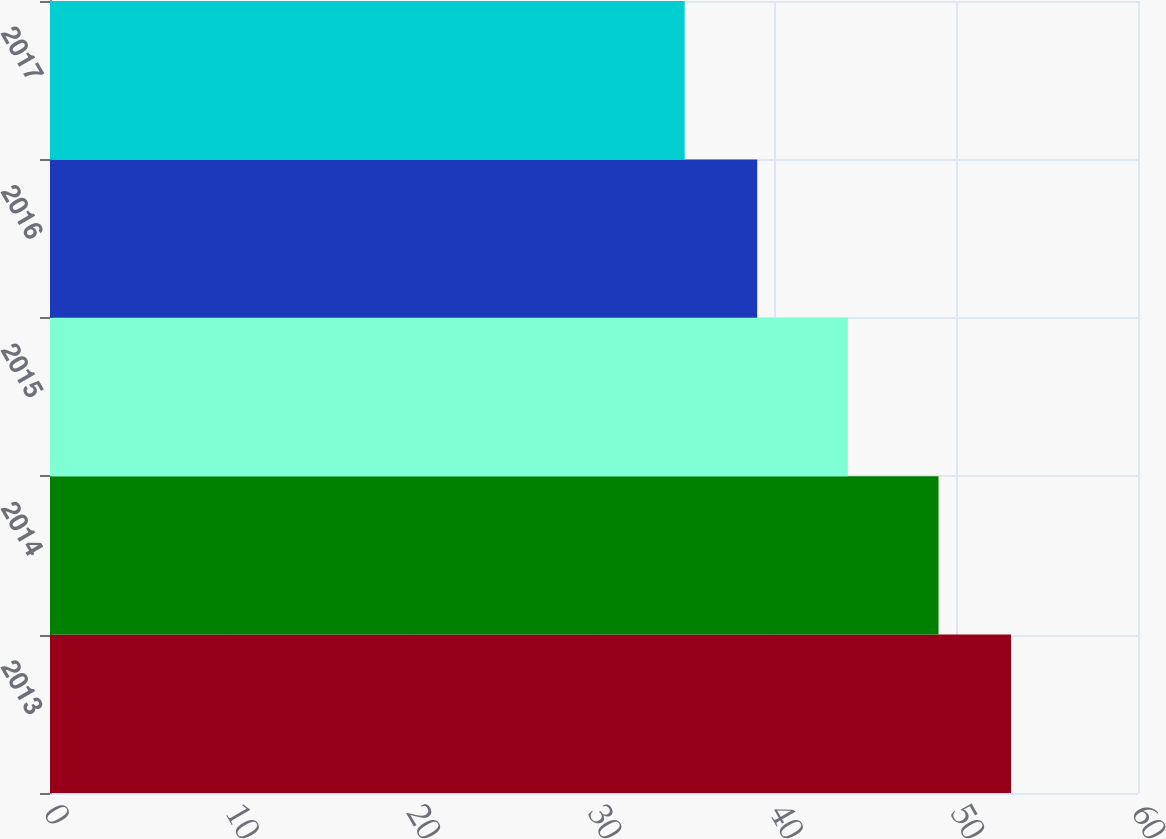<chart> <loc_0><loc_0><loc_500><loc_500><bar_chart><fcel>2013<fcel>2014<fcel>2015<fcel>2016<fcel>2017<nl><fcel>53<fcel>49<fcel>44<fcel>39<fcel>35<nl></chart> 